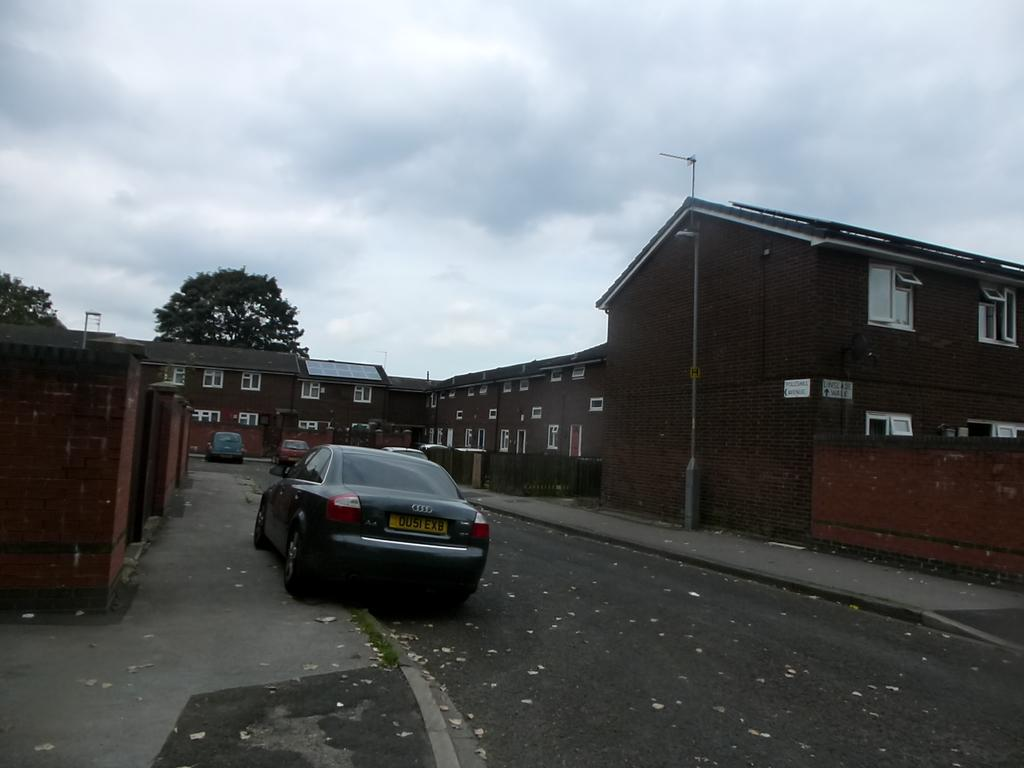What type of structures can be seen in the image? There are buildings in the image. What is happening on the road in the image? Motor vehicles are present on the road in the image. What is on the road that is not a motor vehicle? Shredded leaves are on the road in the image. What are the vertical structures along the road? Street poles are visible in the image. What is attached to the street poles? Street lights are present in the image. What type of vegetation is in the image? Trees are in the image. What is visible above the buildings and trees? The sky is visible in the image. What can be seen in the sky? Clouds are present in the sky. How does the dust affect the control of the motor vehicles in the image? There is no mention of dust in the image, so it cannot affect the control of the motor vehicles. 